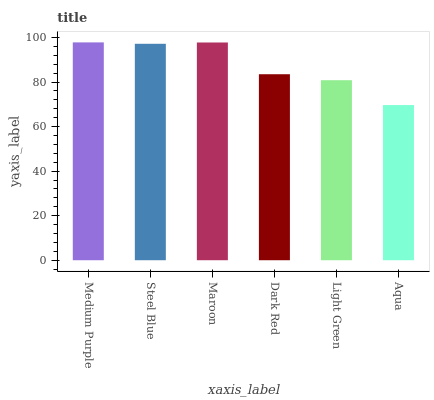Is Steel Blue the minimum?
Answer yes or no. No. Is Steel Blue the maximum?
Answer yes or no. No. Is Medium Purple greater than Steel Blue?
Answer yes or no. Yes. Is Steel Blue less than Medium Purple?
Answer yes or no. Yes. Is Steel Blue greater than Medium Purple?
Answer yes or no. No. Is Medium Purple less than Steel Blue?
Answer yes or no. No. Is Steel Blue the high median?
Answer yes or no. Yes. Is Dark Red the low median?
Answer yes or no. Yes. Is Maroon the high median?
Answer yes or no. No. Is Light Green the low median?
Answer yes or no. No. 